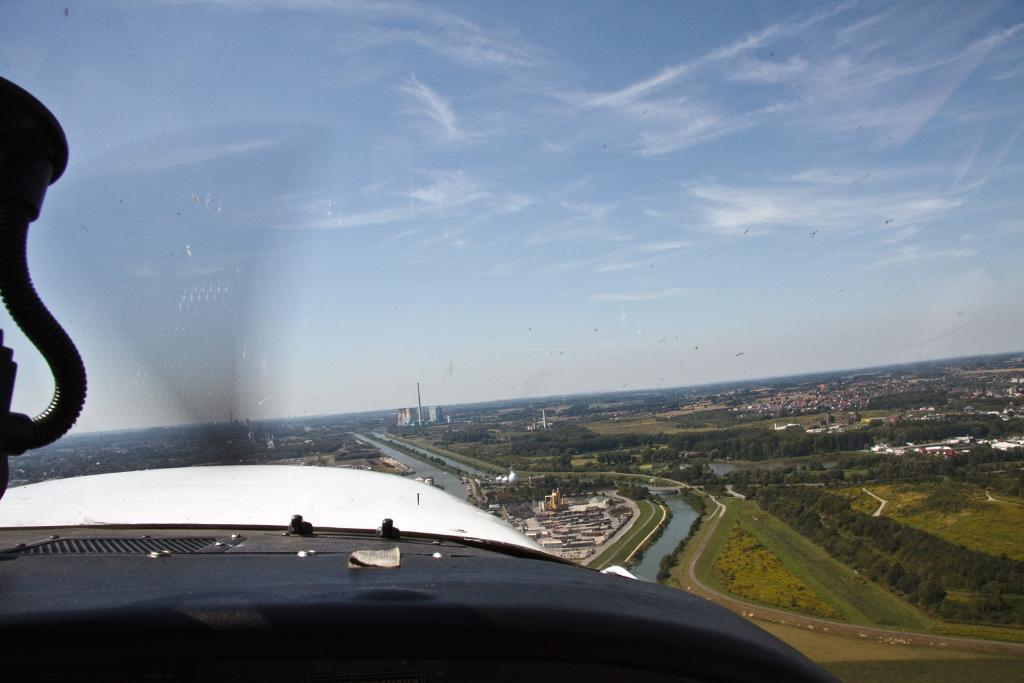What type of view is shown in the image? The image is an aerial view of an area. How would you describe the sky in the image? The sky is blue and cloudy. What natural elements can be seen in the image? There are trees visible in the image. What man-made structures are present in the image? There are buildings in the image. What other natural feature can be seen in the image? There is water visible in the image. Are there any animals visible in the image? Yes, there are birds flying in the air. Can you tell me what time the watch in the image is set to? There is no watch present in the image. What type of glass is used to create the buildings in the image? The image does not provide information about the type of glass used in the buildings. 